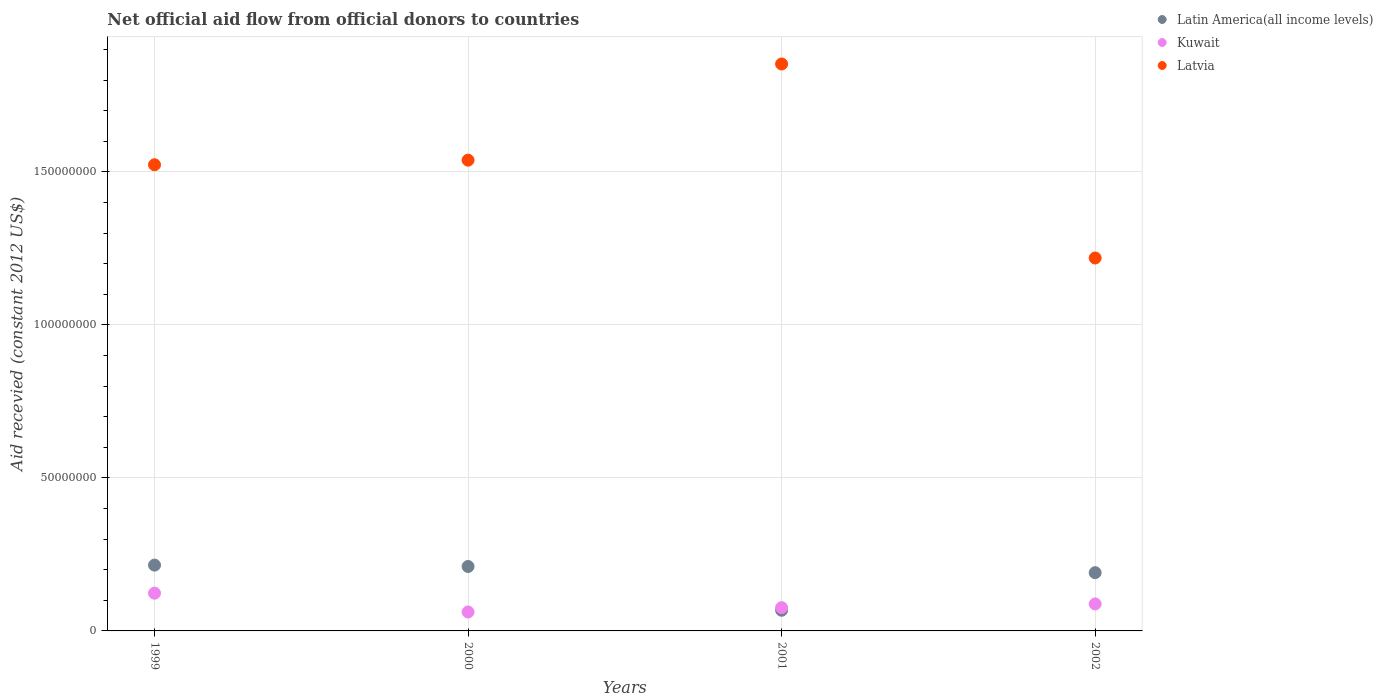What is the total aid received in Latin America(all income levels) in 2002?
Provide a succinct answer. 1.90e+07. Across all years, what is the maximum total aid received in Latvia?
Make the answer very short. 1.85e+08. Across all years, what is the minimum total aid received in Latvia?
Provide a short and direct response. 1.22e+08. What is the total total aid received in Kuwait in the graph?
Your answer should be compact. 3.49e+07. What is the difference between the total aid received in Kuwait in 1999 and that in 2000?
Give a very brief answer. 6.14e+06. What is the difference between the total aid received in Latin America(all income levels) in 2002 and the total aid received in Kuwait in 2001?
Make the answer very short. 1.14e+07. What is the average total aid received in Kuwait per year?
Give a very brief answer. 8.74e+06. In the year 2000, what is the difference between the total aid received in Kuwait and total aid received in Latvia?
Offer a terse response. -1.48e+08. What is the ratio of the total aid received in Latin America(all income levels) in 1999 to that in 2001?
Keep it short and to the point. 3.19. Is the total aid received in Kuwait in 1999 less than that in 2002?
Your answer should be very brief. No. What is the difference between the highest and the second highest total aid received in Latvia?
Give a very brief answer. 3.14e+07. What is the difference between the highest and the lowest total aid received in Latvia?
Ensure brevity in your answer.  6.34e+07. In how many years, is the total aid received in Latin America(all income levels) greater than the average total aid received in Latin America(all income levels) taken over all years?
Offer a very short reply. 3. Is it the case that in every year, the sum of the total aid received in Kuwait and total aid received in Latvia  is greater than the total aid received in Latin America(all income levels)?
Make the answer very short. Yes. How many dotlines are there?
Provide a short and direct response. 3. Does the graph contain grids?
Your response must be concise. Yes. How many legend labels are there?
Make the answer very short. 3. What is the title of the graph?
Keep it short and to the point. Net official aid flow from official donors to countries. Does "Senegal" appear as one of the legend labels in the graph?
Provide a succinct answer. No. What is the label or title of the X-axis?
Your answer should be compact. Years. What is the label or title of the Y-axis?
Your answer should be very brief. Aid recevied (constant 2012 US$). What is the Aid recevied (constant 2012 US$) in Latin America(all income levels) in 1999?
Make the answer very short. 2.15e+07. What is the Aid recevied (constant 2012 US$) in Kuwait in 1999?
Offer a terse response. 1.23e+07. What is the Aid recevied (constant 2012 US$) of Latvia in 1999?
Your response must be concise. 1.52e+08. What is the Aid recevied (constant 2012 US$) in Latin America(all income levels) in 2000?
Offer a terse response. 2.10e+07. What is the Aid recevied (constant 2012 US$) in Kuwait in 2000?
Offer a terse response. 6.19e+06. What is the Aid recevied (constant 2012 US$) in Latvia in 2000?
Keep it short and to the point. 1.54e+08. What is the Aid recevied (constant 2012 US$) in Latin America(all income levels) in 2001?
Provide a succinct answer. 6.75e+06. What is the Aid recevied (constant 2012 US$) of Kuwait in 2001?
Your answer should be compact. 7.60e+06. What is the Aid recevied (constant 2012 US$) of Latvia in 2001?
Your answer should be very brief. 1.85e+08. What is the Aid recevied (constant 2012 US$) in Latin America(all income levels) in 2002?
Offer a terse response. 1.90e+07. What is the Aid recevied (constant 2012 US$) in Kuwait in 2002?
Make the answer very short. 8.82e+06. What is the Aid recevied (constant 2012 US$) of Latvia in 2002?
Your answer should be compact. 1.22e+08. Across all years, what is the maximum Aid recevied (constant 2012 US$) of Latin America(all income levels)?
Provide a succinct answer. 2.15e+07. Across all years, what is the maximum Aid recevied (constant 2012 US$) in Kuwait?
Make the answer very short. 1.23e+07. Across all years, what is the maximum Aid recevied (constant 2012 US$) of Latvia?
Make the answer very short. 1.85e+08. Across all years, what is the minimum Aid recevied (constant 2012 US$) of Latin America(all income levels)?
Provide a succinct answer. 6.75e+06. Across all years, what is the minimum Aid recevied (constant 2012 US$) of Kuwait?
Your answer should be very brief. 6.19e+06. Across all years, what is the minimum Aid recevied (constant 2012 US$) in Latvia?
Provide a succinct answer. 1.22e+08. What is the total Aid recevied (constant 2012 US$) in Latin America(all income levels) in the graph?
Offer a very short reply. 6.83e+07. What is the total Aid recevied (constant 2012 US$) of Kuwait in the graph?
Keep it short and to the point. 3.49e+07. What is the total Aid recevied (constant 2012 US$) in Latvia in the graph?
Offer a very short reply. 6.13e+08. What is the difference between the Aid recevied (constant 2012 US$) of Kuwait in 1999 and that in 2000?
Ensure brevity in your answer.  6.14e+06. What is the difference between the Aid recevied (constant 2012 US$) of Latvia in 1999 and that in 2000?
Provide a short and direct response. -1.50e+06. What is the difference between the Aid recevied (constant 2012 US$) in Latin America(all income levels) in 1999 and that in 2001?
Offer a very short reply. 1.48e+07. What is the difference between the Aid recevied (constant 2012 US$) in Kuwait in 1999 and that in 2001?
Offer a terse response. 4.73e+06. What is the difference between the Aid recevied (constant 2012 US$) of Latvia in 1999 and that in 2001?
Give a very brief answer. -3.29e+07. What is the difference between the Aid recevied (constant 2012 US$) of Latin America(all income levels) in 1999 and that in 2002?
Your answer should be very brief. 2.47e+06. What is the difference between the Aid recevied (constant 2012 US$) in Kuwait in 1999 and that in 2002?
Your answer should be very brief. 3.51e+06. What is the difference between the Aid recevied (constant 2012 US$) of Latvia in 1999 and that in 2002?
Your answer should be very brief. 3.05e+07. What is the difference between the Aid recevied (constant 2012 US$) of Latin America(all income levels) in 2000 and that in 2001?
Ensure brevity in your answer.  1.43e+07. What is the difference between the Aid recevied (constant 2012 US$) of Kuwait in 2000 and that in 2001?
Keep it short and to the point. -1.41e+06. What is the difference between the Aid recevied (constant 2012 US$) of Latvia in 2000 and that in 2001?
Offer a very short reply. -3.14e+07. What is the difference between the Aid recevied (constant 2012 US$) of Latin America(all income levels) in 2000 and that in 2002?
Keep it short and to the point. 2.02e+06. What is the difference between the Aid recevied (constant 2012 US$) of Kuwait in 2000 and that in 2002?
Your answer should be compact. -2.63e+06. What is the difference between the Aid recevied (constant 2012 US$) in Latvia in 2000 and that in 2002?
Offer a terse response. 3.20e+07. What is the difference between the Aid recevied (constant 2012 US$) of Latin America(all income levels) in 2001 and that in 2002?
Offer a terse response. -1.23e+07. What is the difference between the Aid recevied (constant 2012 US$) in Kuwait in 2001 and that in 2002?
Offer a very short reply. -1.22e+06. What is the difference between the Aid recevied (constant 2012 US$) in Latvia in 2001 and that in 2002?
Your response must be concise. 6.34e+07. What is the difference between the Aid recevied (constant 2012 US$) in Latin America(all income levels) in 1999 and the Aid recevied (constant 2012 US$) in Kuwait in 2000?
Offer a terse response. 1.53e+07. What is the difference between the Aid recevied (constant 2012 US$) of Latin America(all income levels) in 1999 and the Aid recevied (constant 2012 US$) of Latvia in 2000?
Ensure brevity in your answer.  -1.32e+08. What is the difference between the Aid recevied (constant 2012 US$) of Kuwait in 1999 and the Aid recevied (constant 2012 US$) of Latvia in 2000?
Ensure brevity in your answer.  -1.41e+08. What is the difference between the Aid recevied (constant 2012 US$) of Latin America(all income levels) in 1999 and the Aid recevied (constant 2012 US$) of Kuwait in 2001?
Make the answer very short. 1.39e+07. What is the difference between the Aid recevied (constant 2012 US$) of Latin America(all income levels) in 1999 and the Aid recevied (constant 2012 US$) of Latvia in 2001?
Your answer should be compact. -1.64e+08. What is the difference between the Aid recevied (constant 2012 US$) in Kuwait in 1999 and the Aid recevied (constant 2012 US$) in Latvia in 2001?
Give a very brief answer. -1.73e+08. What is the difference between the Aid recevied (constant 2012 US$) in Latin America(all income levels) in 1999 and the Aid recevied (constant 2012 US$) in Kuwait in 2002?
Your response must be concise. 1.27e+07. What is the difference between the Aid recevied (constant 2012 US$) in Latin America(all income levels) in 1999 and the Aid recevied (constant 2012 US$) in Latvia in 2002?
Make the answer very short. -1.00e+08. What is the difference between the Aid recevied (constant 2012 US$) of Kuwait in 1999 and the Aid recevied (constant 2012 US$) of Latvia in 2002?
Your response must be concise. -1.10e+08. What is the difference between the Aid recevied (constant 2012 US$) of Latin America(all income levels) in 2000 and the Aid recevied (constant 2012 US$) of Kuwait in 2001?
Offer a terse response. 1.34e+07. What is the difference between the Aid recevied (constant 2012 US$) in Latin America(all income levels) in 2000 and the Aid recevied (constant 2012 US$) in Latvia in 2001?
Make the answer very short. -1.64e+08. What is the difference between the Aid recevied (constant 2012 US$) of Kuwait in 2000 and the Aid recevied (constant 2012 US$) of Latvia in 2001?
Your answer should be compact. -1.79e+08. What is the difference between the Aid recevied (constant 2012 US$) in Latin America(all income levels) in 2000 and the Aid recevied (constant 2012 US$) in Kuwait in 2002?
Give a very brief answer. 1.22e+07. What is the difference between the Aid recevied (constant 2012 US$) in Latin America(all income levels) in 2000 and the Aid recevied (constant 2012 US$) in Latvia in 2002?
Make the answer very short. -1.01e+08. What is the difference between the Aid recevied (constant 2012 US$) of Kuwait in 2000 and the Aid recevied (constant 2012 US$) of Latvia in 2002?
Ensure brevity in your answer.  -1.16e+08. What is the difference between the Aid recevied (constant 2012 US$) of Latin America(all income levels) in 2001 and the Aid recevied (constant 2012 US$) of Kuwait in 2002?
Your response must be concise. -2.07e+06. What is the difference between the Aid recevied (constant 2012 US$) in Latin America(all income levels) in 2001 and the Aid recevied (constant 2012 US$) in Latvia in 2002?
Ensure brevity in your answer.  -1.15e+08. What is the difference between the Aid recevied (constant 2012 US$) in Kuwait in 2001 and the Aid recevied (constant 2012 US$) in Latvia in 2002?
Offer a terse response. -1.14e+08. What is the average Aid recevied (constant 2012 US$) in Latin America(all income levels) per year?
Offer a very short reply. 1.71e+07. What is the average Aid recevied (constant 2012 US$) of Kuwait per year?
Keep it short and to the point. 8.74e+06. What is the average Aid recevied (constant 2012 US$) of Latvia per year?
Your answer should be very brief. 1.53e+08. In the year 1999, what is the difference between the Aid recevied (constant 2012 US$) in Latin America(all income levels) and Aid recevied (constant 2012 US$) in Kuwait?
Keep it short and to the point. 9.17e+06. In the year 1999, what is the difference between the Aid recevied (constant 2012 US$) of Latin America(all income levels) and Aid recevied (constant 2012 US$) of Latvia?
Provide a short and direct response. -1.31e+08. In the year 1999, what is the difference between the Aid recevied (constant 2012 US$) of Kuwait and Aid recevied (constant 2012 US$) of Latvia?
Provide a succinct answer. -1.40e+08. In the year 2000, what is the difference between the Aid recevied (constant 2012 US$) of Latin America(all income levels) and Aid recevied (constant 2012 US$) of Kuwait?
Give a very brief answer. 1.49e+07. In the year 2000, what is the difference between the Aid recevied (constant 2012 US$) in Latin America(all income levels) and Aid recevied (constant 2012 US$) in Latvia?
Give a very brief answer. -1.33e+08. In the year 2000, what is the difference between the Aid recevied (constant 2012 US$) of Kuwait and Aid recevied (constant 2012 US$) of Latvia?
Your answer should be compact. -1.48e+08. In the year 2001, what is the difference between the Aid recevied (constant 2012 US$) in Latin America(all income levels) and Aid recevied (constant 2012 US$) in Kuwait?
Offer a very short reply. -8.50e+05. In the year 2001, what is the difference between the Aid recevied (constant 2012 US$) in Latin America(all income levels) and Aid recevied (constant 2012 US$) in Latvia?
Your response must be concise. -1.78e+08. In the year 2001, what is the difference between the Aid recevied (constant 2012 US$) of Kuwait and Aid recevied (constant 2012 US$) of Latvia?
Offer a very short reply. -1.78e+08. In the year 2002, what is the difference between the Aid recevied (constant 2012 US$) of Latin America(all income levels) and Aid recevied (constant 2012 US$) of Kuwait?
Your response must be concise. 1.02e+07. In the year 2002, what is the difference between the Aid recevied (constant 2012 US$) of Latin America(all income levels) and Aid recevied (constant 2012 US$) of Latvia?
Your answer should be very brief. -1.03e+08. In the year 2002, what is the difference between the Aid recevied (constant 2012 US$) in Kuwait and Aid recevied (constant 2012 US$) in Latvia?
Your answer should be very brief. -1.13e+08. What is the ratio of the Aid recevied (constant 2012 US$) in Latin America(all income levels) in 1999 to that in 2000?
Your answer should be compact. 1.02. What is the ratio of the Aid recevied (constant 2012 US$) of Kuwait in 1999 to that in 2000?
Make the answer very short. 1.99. What is the ratio of the Aid recevied (constant 2012 US$) in Latvia in 1999 to that in 2000?
Offer a terse response. 0.99. What is the ratio of the Aid recevied (constant 2012 US$) in Latin America(all income levels) in 1999 to that in 2001?
Ensure brevity in your answer.  3.19. What is the ratio of the Aid recevied (constant 2012 US$) of Kuwait in 1999 to that in 2001?
Provide a succinct answer. 1.62. What is the ratio of the Aid recevied (constant 2012 US$) of Latvia in 1999 to that in 2001?
Your answer should be very brief. 0.82. What is the ratio of the Aid recevied (constant 2012 US$) of Latin America(all income levels) in 1999 to that in 2002?
Provide a succinct answer. 1.13. What is the ratio of the Aid recevied (constant 2012 US$) of Kuwait in 1999 to that in 2002?
Your answer should be very brief. 1.4. What is the ratio of the Aid recevied (constant 2012 US$) of Latin America(all income levels) in 2000 to that in 2001?
Give a very brief answer. 3.12. What is the ratio of the Aid recevied (constant 2012 US$) of Kuwait in 2000 to that in 2001?
Your answer should be compact. 0.81. What is the ratio of the Aid recevied (constant 2012 US$) of Latvia in 2000 to that in 2001?
Your answer should be very brief. 0.83. What is the ratio of the Aid recevied (constant 2012 US$) in Latin America(all income levels) in 2000 to that in 2002?
Keep it short and to the point. 1.11. What is the ratio of the Aid recevied (constant 2012 US$) in Kuwait in 2000 to that in 2002?
Your answer should be very brief. 0.7. What is the ratio of the Aid recevied (constant 2012 US$) in Latvia in 2000 to that in 2002?
Your response must be concise. 1.26. What is the ratio of the Aid recevied (constant 2012 US$) in Latin America(all income levels) in 2001 to that in 2002?
Your answer should be very brief. 0.35. What is the ratio of the Aid recevied (constant 2012 US$) in Kuwait in 2001 to that in 2002?
Give a very brief answer. 0.86. What is the ratio of the Aid recevied (constant 2012 US$) in Latvia in 2001 to that in 2002?
Offer a very short reply. 1.52. What is the difference between the highest and the second highest Aid recevied (constant 2012 US$) of Kuwait?
Offer a very short reply. 3.51e+06. What is the difference between the highest and the second highest Aid recevied (constant 2012 US$) in Latvia?
Your answer should be compact. 3.14e+07. What is the difference between the highest and the lowest Aid recevied (constant 2012 US$) in Latin America(all income levels)?
Offer a terse response. 1.48e+07. What is the difference between the highest and the lowest Aid recevied (constant 2012 US$) in Kuwait?
Offer a very short reply. 6.14e+06. What is the difference between the highest and the lowest Aid recevied (constant 2012 US$) in Latvia?
Your answer should be very brief. 6.34e+07. 